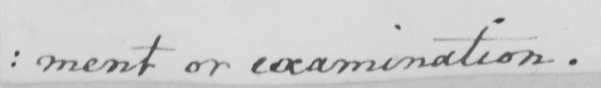Please transcribe the handwritten text in this image. ment or examination . 